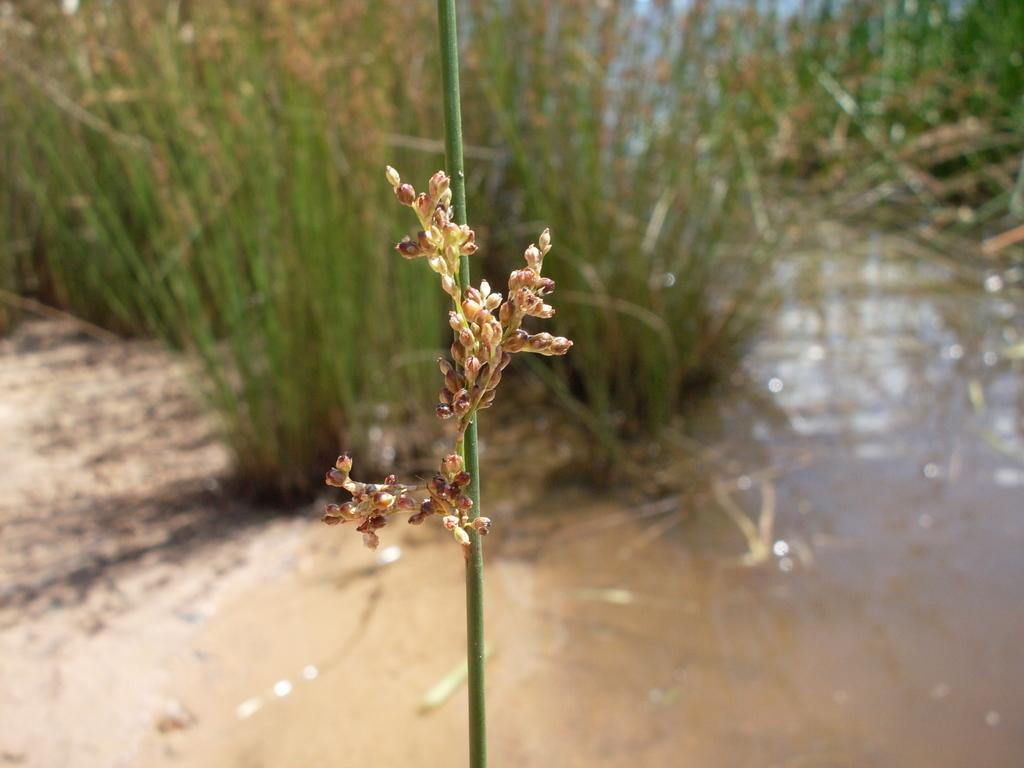What type of vegetation is present in the image? There are grass plants in the image. What else can be seen in the image besides the grass plants? There is water visible in the image. What time of day is depicted in the image? The time of day cannot be determined from the image, as there are no specific indicators of time. 